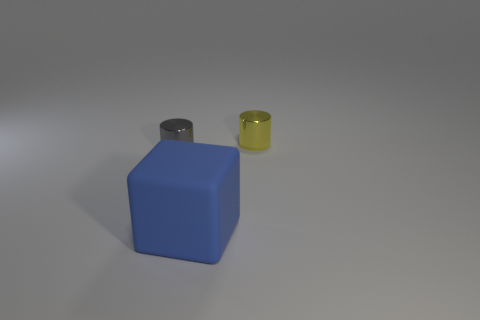Add 2 large objects. How many objects exist? 5 Subtract 0 brown cylinders. How many objects are left? 3 Subtract all cubes. How many objects are left? 2 Subtract all large gray matte blocks. Subtract all large blue matte objects. How many objects are left? 2 Add 1 blue objects. How many blue objects are left? 2 Add 2 large blue matte blocks. How many large blue matte blocks exist? 3 